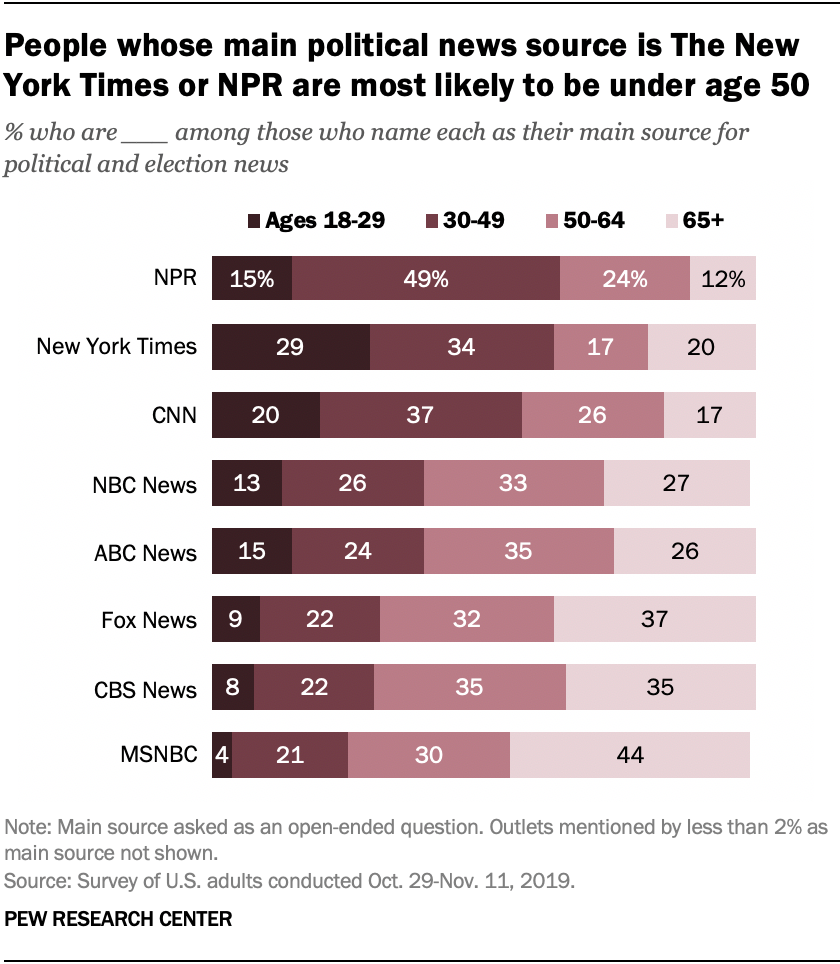Identify some key points in this picture. The 30-49 age group bar for these two news channels is equivalent to 22. Is the 18-29 age group bars displaying the darkest color? Yes. 